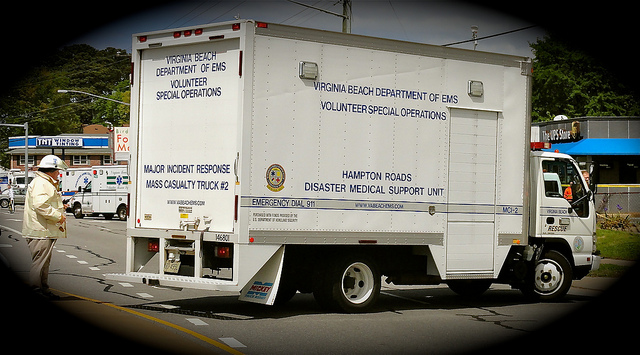Extract all visible text content from this image. WIEGINIA BNEACH DEPARTMENT OF EMS SPECIAL OPERATIONS VIRGINIA BEACH DEPARTMENT VOLUNTEER SPECIAL OPERATIONS MAJOR INCIDENT RESPONSE THT CF EMS DISASTER HAMPTON ROADS MEDICAL SUPPORT UNIT 911 VOLUTEER DUAL EMERGENCY 2 TRUCK CASUALITY MASS M 